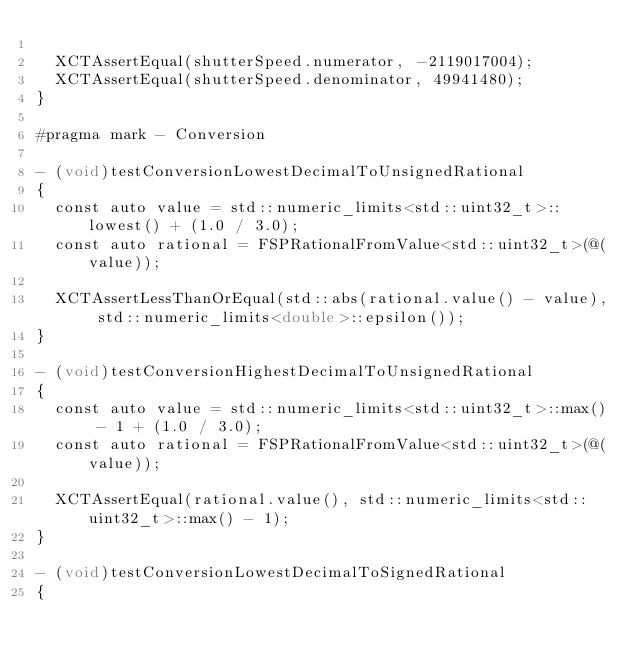<code> <loc_0><loc_0><loc_500><loc_500><_ObjectiveC_>
  XCTAssertEqual(shutterSpeed.numerator, -2119017004);
  XCTAssertEqual(shutterSpeed.denominator, 49941480);
}

#pragma mark - Conversion

- (void)testConversionLowestDecimalToUnsignedRational
{
  const auto value = std::numeric_limits<std::uint32_t>::lowest() + (1.0 / 3.0);
  const auto rational = FSPRationalFromValue<std::uint32_t>(@(value));

  XCTAssertLessThanOrEqual(std::abs(rational.value() - value), std::numeric_limits<double>::epsilon());
}

- (void)testConversionHighestDecimalToUnsignedRational
{
  const auto value = std::numeric_limits<std::uint32_t>::max() - 1 + (1.0 / 3.0);
  const auto rational = FSPRationalFromValue<std::uint32_t>(@(value));

  XCTAssertEqual(rational.value(), std::numeric_limits<std::uint32_t>::max() - 1);
}

- (void)testConversionLowestDecimalToSignedRational
{</code> 